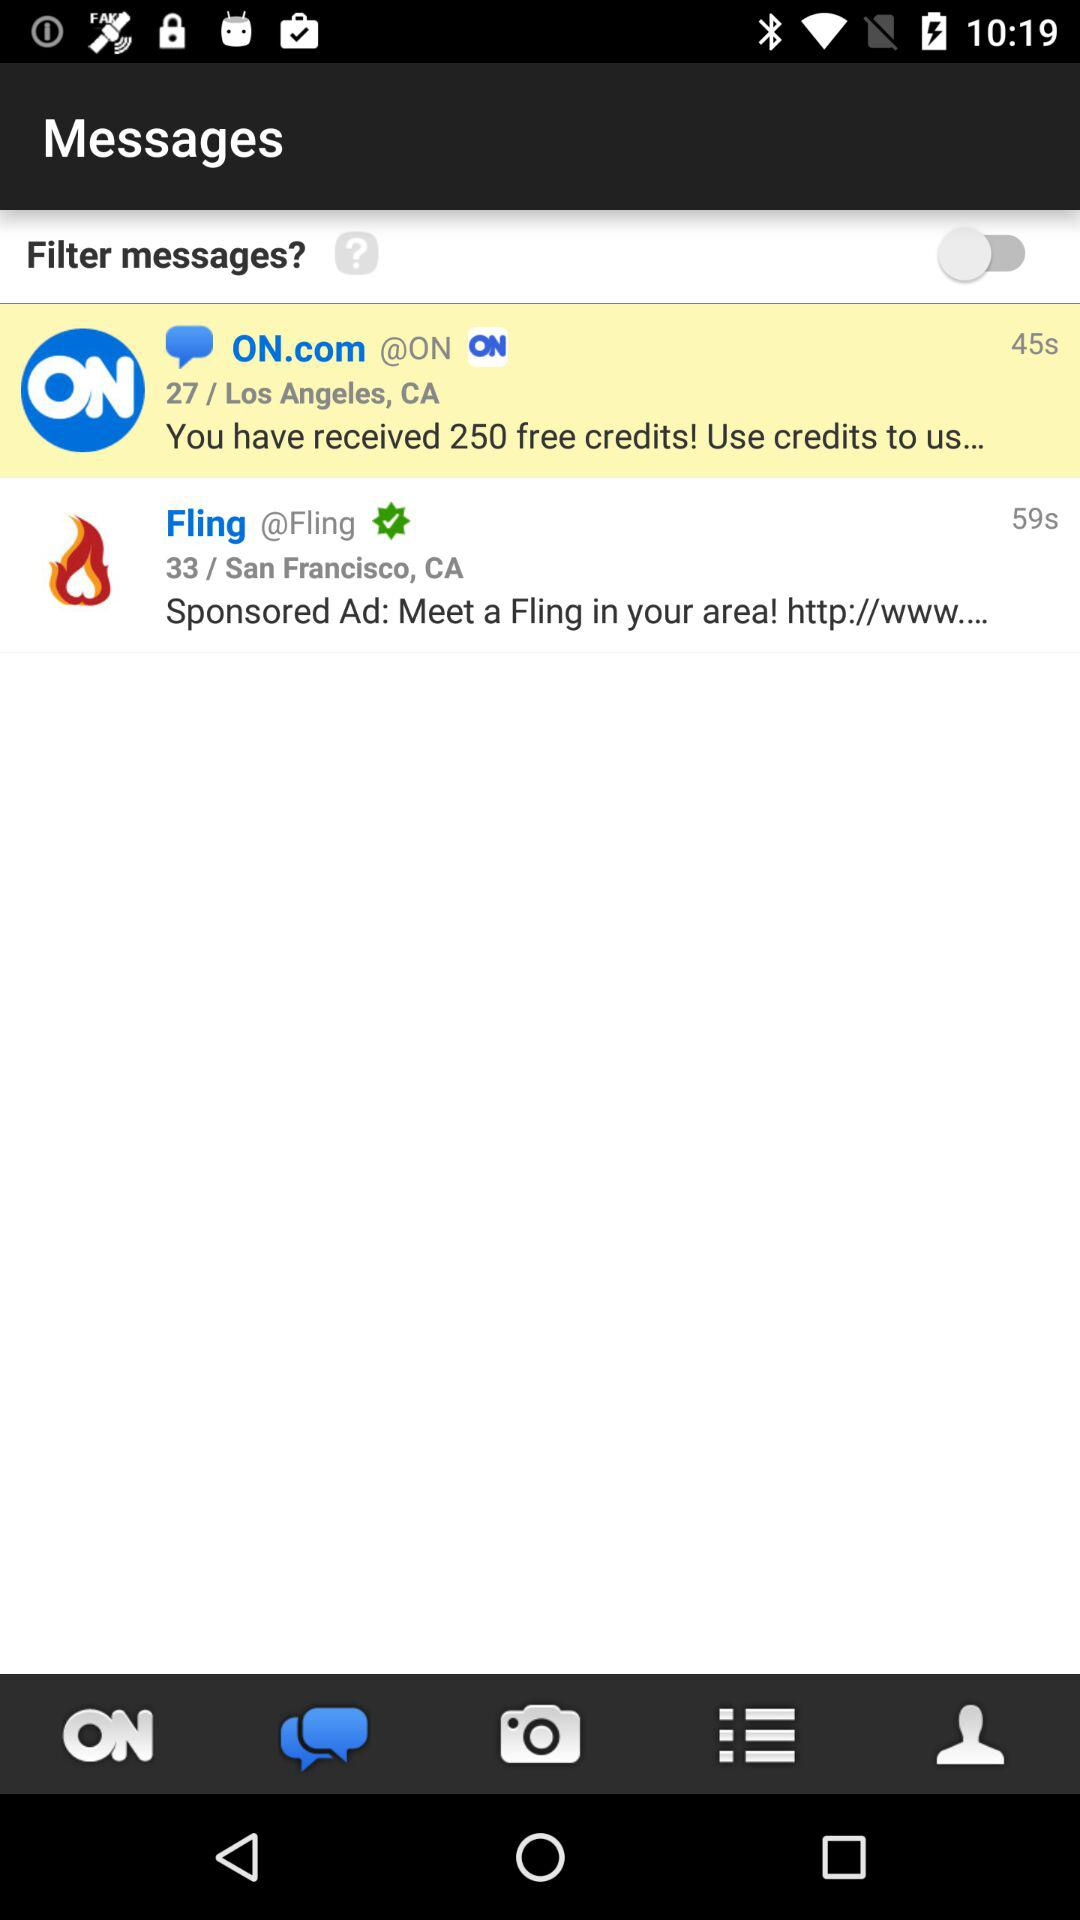What is the status of "Filter messages?"? The status is "off". 